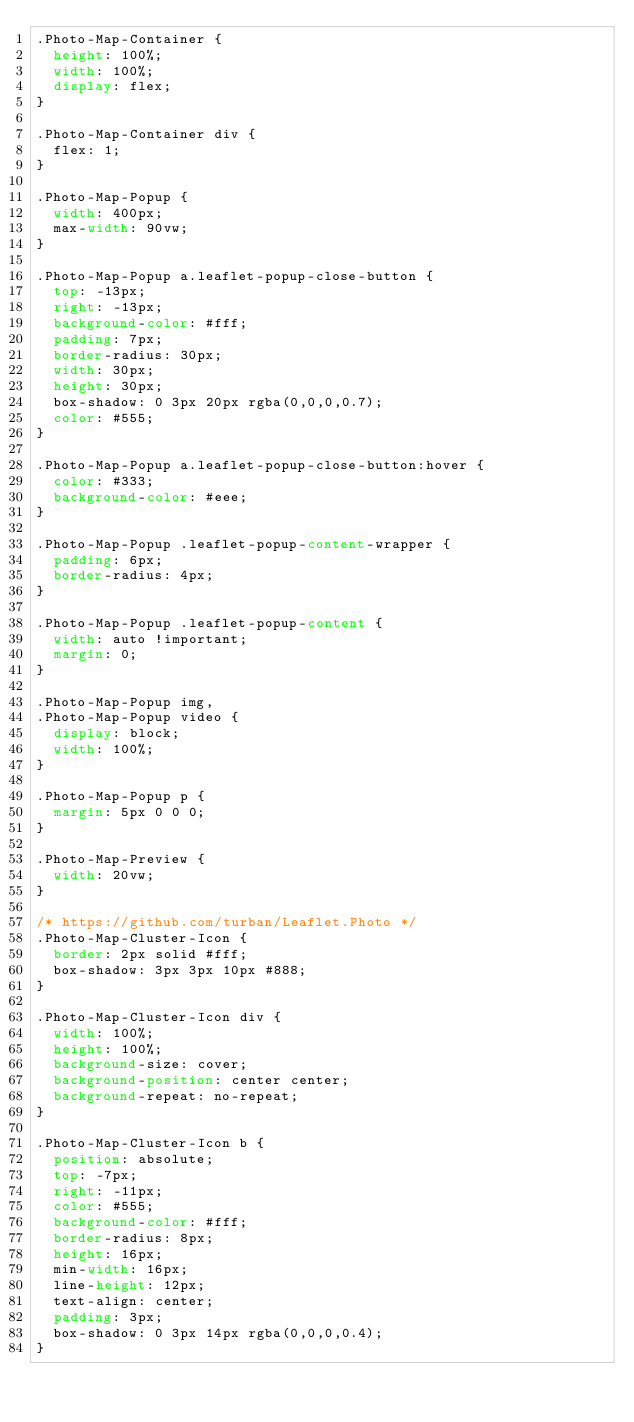<code> <loc_0><loc_0><loc_500><loc_500><_CSS_>.Photo-Map-Container {
  height: 100%;
  width: 100%;
  display: flex;
}

.Photo-Map-Container div {
  flex: 1;
}

.Photo-Map-Popup {
  width: 400px;
  max-width: 90vw;
}

.Photo-Map-Popup a.leaflet-popup-close-button {
  top: -13px;
  right: -13px;
  background-color: #fff;
  padding: 7px;
  border-radius: 30px;
  width: 30px;
  height: 30px;
  box-shadow: 0 3px 20px rgba(0,0,0,0.7);
  color: #555;
}

.Photo-Map-Popup a.leaflet-popup-close-button:hover {
  color: #333;
  background-color: #eee;
}

.Photo-Map-Popup .leaflet-popup-content-wrapper {
  padding: 6px;
  border-radius: 4px;
}

.Photo-Map-Popup .leaflet-popup-content {
  width: auto !important;
  margin: 0;
}

.Photo-Map-Popup img,
.Photo-Map-Popup video {
  display: block;
  width: 100%;
}

.Photo-Map-Popup p {
  margin: 5px 0 0 0;
}

.Photo-Map-Preview {
  width: 20vw;
}

/* https://github.com/turban/Leaflet.Photo */
.Photo-Map-Cluster-Icon {
  border: 2px solid #fff;
  box-shadow: 3px 3px 10px #888;
}

.Photo-Map-Cluster-Icon div {
  width: 100%;
  height: 100%;
  background-size: cover;
  background-position: center center;
  background-repeat: no-repeat;
}

.Photo-Map-Cluster-Icon b {
  position: absolute;
  top: -7px;
  right: -11px;
  color: #555;
  background-color: #fff;
  border-radius: 8px;
  height: 16px;
  min-width: 16px;
  line-height: 12px;
  text-align: center;
  padding: 3px;
  box-shadow: 0 3px 14px rgba(0,0,0,0.4);
}
</code> 